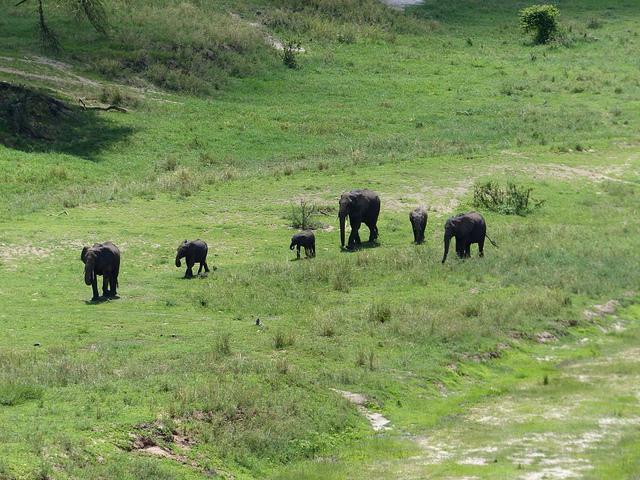How many animals are walking?
Give a very brief answer. 6. 